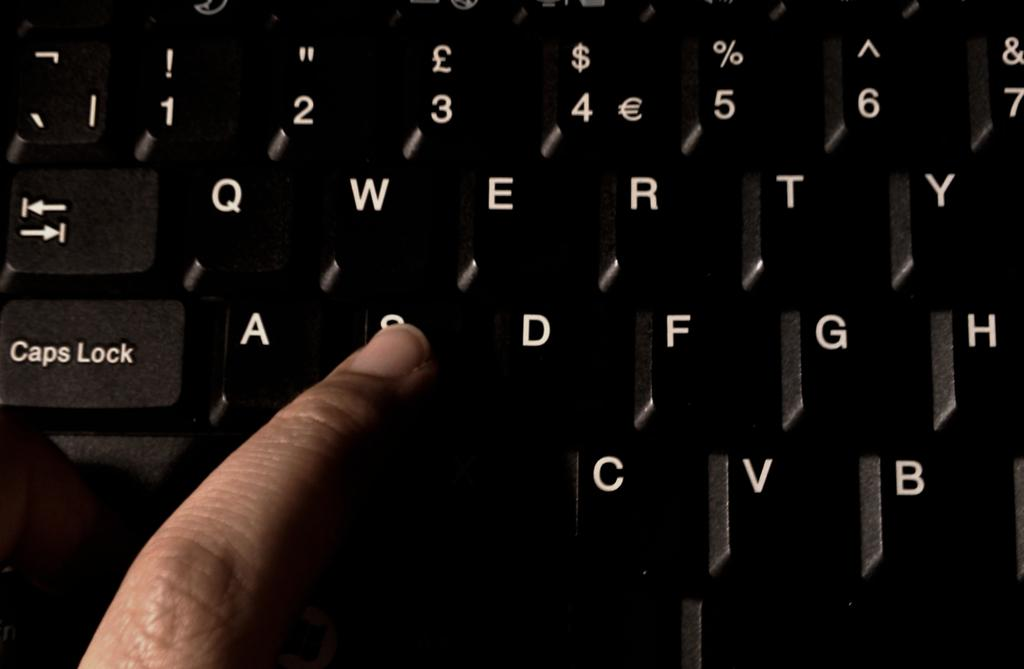<image>
Offer a succinct explanation of the picture presented. A person pressing the "S" key on a computer keyboard. 